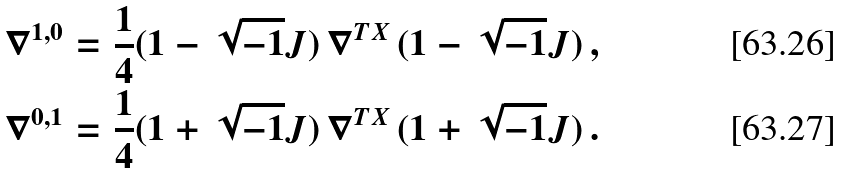Convert formula to latex. <formula><loc_0><loc_0><loc_500><loc_500>\nabla ^ { 1 , 0 } & = \frac { 1 } { 4 } ( 1 - \sqrt { - 1 } J ) \, \nabla ^ { T X } \, ( 1 - \sqrt { - 1 } J ) \, , \\ \nabla ^ { 0 , 1 } & = \frac { 1 } { 4 } ( 1 + \sqrt { - 1 } J ) \, \nabla ^ { T X } \, ( 1 + \sqrt { - 1 } J ) \, .</formula> 